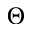Convert formula to latex. <formula><loc_0><loc_0><loc_500><loc_500>\Theta</formula> 